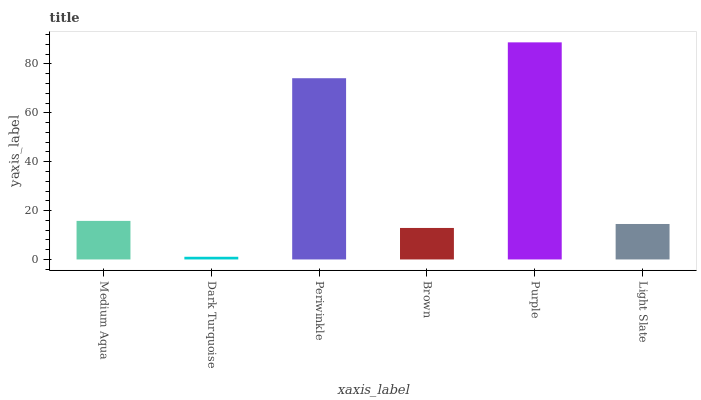Is Dark Turquoise the minimum?
Answer yes or no. Yes. Is Purple the maximum?
Answer yes or no. Yes. Is Periwinkle the minimum?
Answer yes or no. No. Is Periwinkle the maximum?
Answer yes or no. No. Is Periwinkle greater than Dark Turquoise?
Answer yes or no. Yes. Is Dark Turquoise less than Periwinkle?
Answer yes or no. Yes. Is Dark Turquoise greater than Periwinkle?
Answer yes or no. No. Is Periwinkle less than Dark Turquoise?
Answer yes or no. No. Is Medium Aqua the high median?
Answer yes or no. Yes. Is Light Slate the low median?
Answer yes or no. Yes. Is Purple the high median?
Answer yes or no. No. Is Purple the low median?
Answer yes or no. No. 